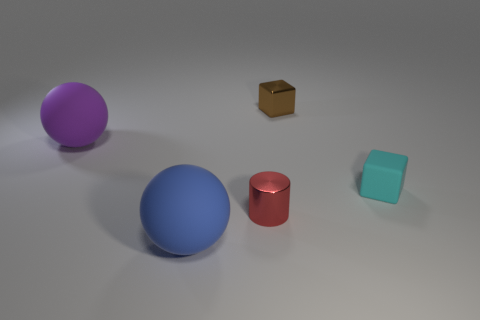What is the tiny object in front of the cyan matte object made of?
Provide a succinct answer. Metal. Is the number of tiny cyan matte things that are in front of the small cylinder the same as the number of blue spheres?
Provide a succinct answer. No. What color is the other tiny thing that is the same shape as the brown object?
Your answer should be very brief. Cyan. Do the purple matte object and the cyan object have the same size?
Make the answer very short. No. Is the number of big purple matte things in front of the small cyan matte thing the same as the number of large purple spheres that are to the left of the metallic cylinder?
Offer a terse response. No. Is there a small red shiny cylinder?
Your response must be concise. Yes. The blue thing that is the same shape as the big purple rubber thing is what size?
Provide a short and direct response. Large. There is a ball on the left side of the big blue ball; how big is it?
Offer a terse response. Large. Is the number of shiny cylinders that are right of the purple rubber object greater than the number of small green metallic cubes?
Your response must be concise. Yes. What shape is the red metal object?
Your response must be concise. Cylinder. 